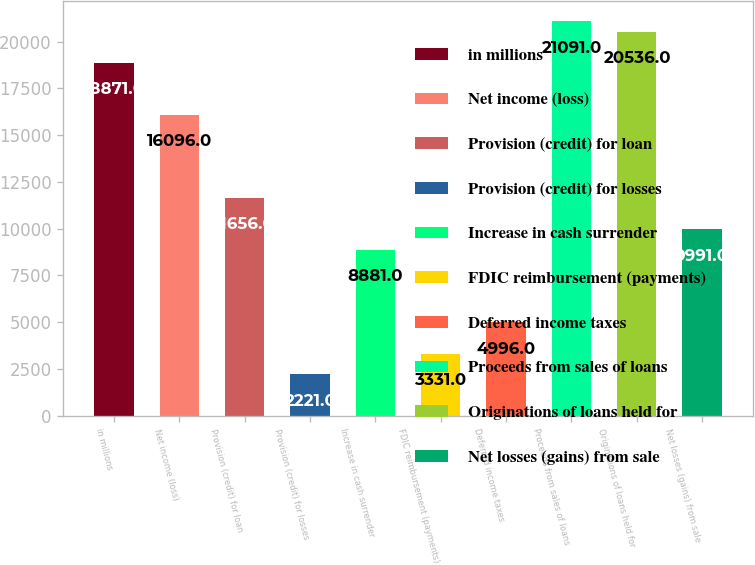Convert chart. <chart><loc_0><loc_0><loc_500><loc_500><bar_chart><fcel>in millions<fcel>Net income (loss)<fcel>Provision (credit) for loan<fcel>Provision (credit) for losses<fcel>Increase in cash surrender<fcel>FDIC reimbursement (payments)<fcel>Deferred income taxes<fcel>Proceeds from sales of loans<fcel>Originations of loans held for<fcel>Net losses (gains) from sale<nl><fcel>18871<fcel>16096<fcel>11656<fcel>2221<fcel>8881<fcel>3331<fcel>4996<fcel>21091<fcel>20536<fcel>9991<nl></chart> 